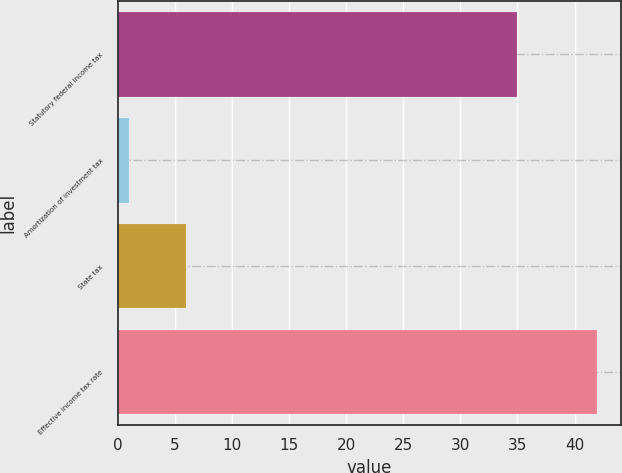Convert chart to OTSL. <chart><loc_0><loc_0><loc_500><loc_500><bar_chart><fcel>Statutory federal income tax<fcel>Amortization of investment tax<fcel>State tax<fcel>Effective income tax rate<nl><fcel>35<fcel>1<fcel>6<fcel>42<nl></chart> 